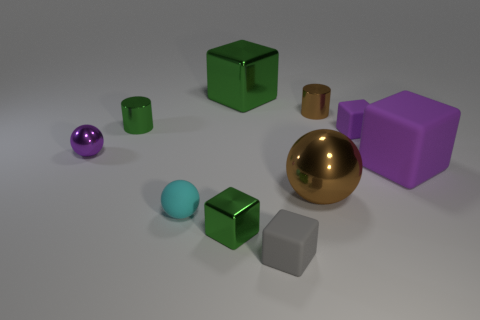What number of green things are either small cubes or large matte objects?
Offer a very short reply. 1. Do the metallic thing in front of the big metallic sphere and the green metallic block behind the big ball have the same size?
Ensure brevity in your answer.  No. How many things are blue matte cylinders or big blocks?
Provide a succinct answer. 2. Are there any other objects of the same shape as the cyan rubber thing?
Your answer should be compact. Yes. Is the number of matte balls less than the number of big gray cylinders?
Your response must be concise. No. Is the large green thing the same shape as the gray matte thing?
Make the answer very short. Yes. How many objects are purple balls or purple shiny spheres behind the cyan ball?
Your answer should be very brief. 1. What number of tiny matte cubes are there?
Keep it short and to the point. 2. Are there any matte objects that have the same size as the brown metal sphere?
Make the answer very short. Yes. Is the number of brown metal cylinders right of the small purple matte object less than the number of brown shiny cylinders?
Your answer should be very brief. Yes. 